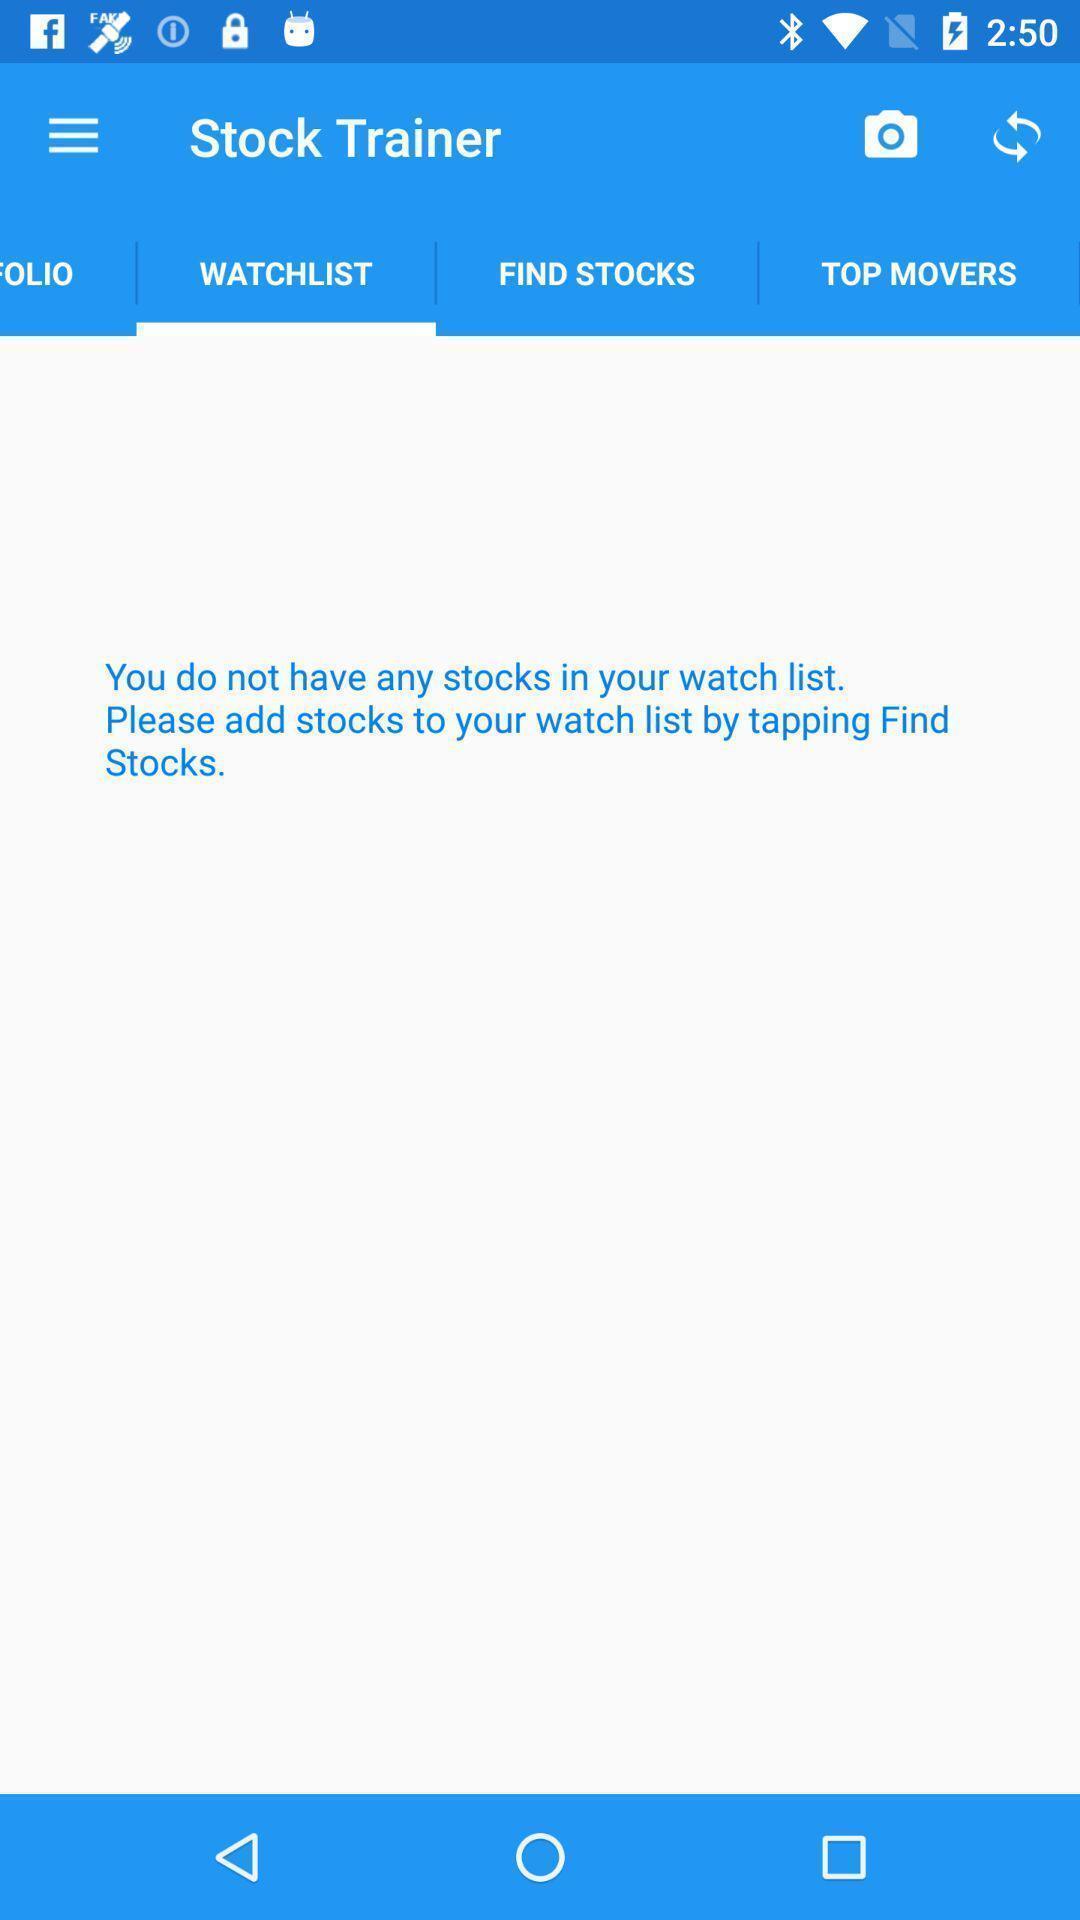Tell me what you see in this picture. Page showing your wishlist in the trading app. 